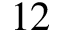<formula> <loc_0><loc_0><loc_500><loc_500>1 2</formula> 